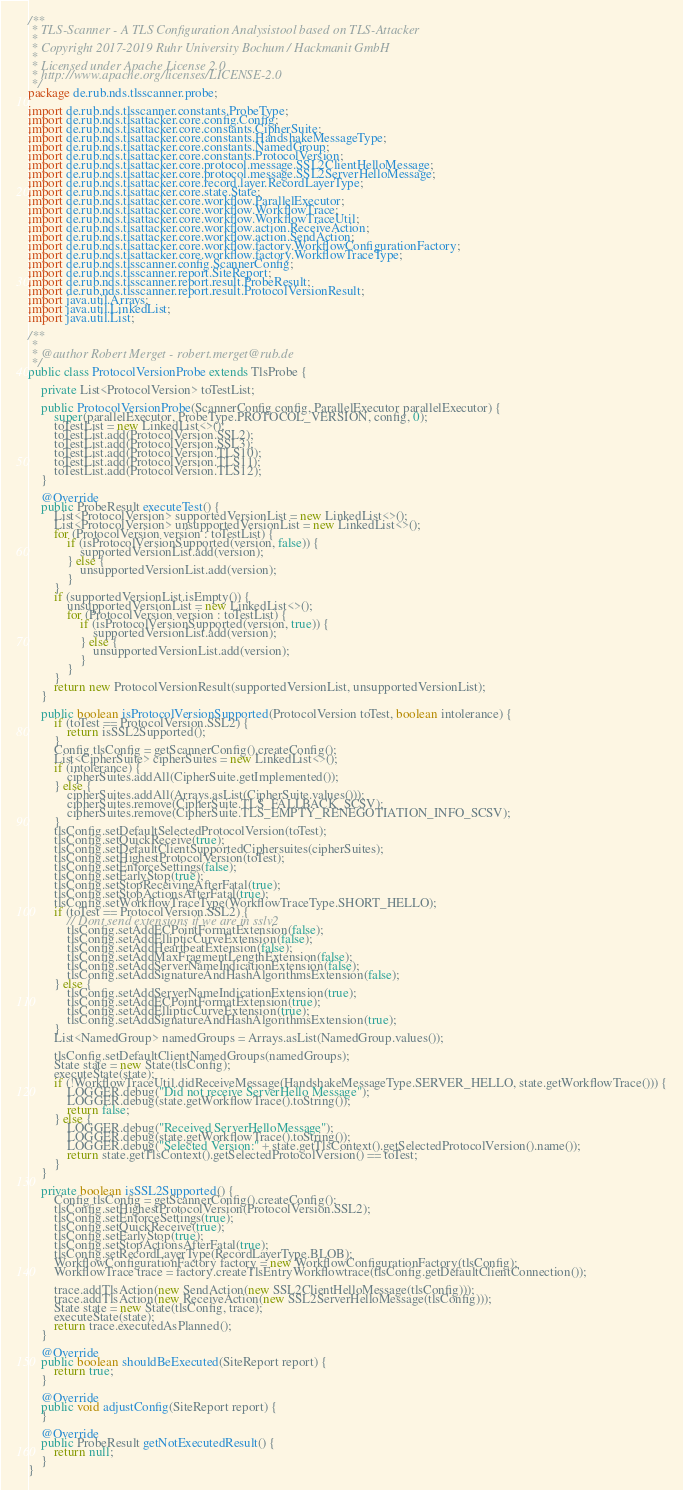Convert code to text. <code><loc_0><loc_0><loc_500><loc_500><_Java_>/**
 * TLS-Scanner - A TLS Configuration Analysistool based on TLS-Attacker
 *
 * Copyright 2017-2019 Ruhr University Bochum / Hackmanit GmbH
 *
 * Licensed under Apache License 2.0
 * http://www.apache.org/licenses/LICENSE-2.0
 */
package de.rub.nds.tlsscanner.probe;

import de.rub.nds.tlsscanner.constants.ProbeType;
import de.rub.nds.tlsattacker.core.config.Config;
import de.rub.nds.tlsattacker.core.constants.CipherSuite;
import de.rub.nds.tlsattacker.core.constants.HandshakeMessageType;
import de.rub.nds.tlsattacker.core.constants.NamedGroup;
import de.rub.nds.tlsattacker.core.constants.ProtocolVersion;
import de.rub.nds.tlsattacker.core.protocol.message.SSL2ClientHelloMessage;
import de.rub.nds.tlsattacker.core.protocol.message.SSL2ServerHelloMessage;
import de.rub.nds.tlsattacker.core.record.layer.RecordLayerType;
import de.rub.nds.tlsattacker.core.state.State;
import de.rub.nds.tlsattacker.core.workflow.ParallelExecutor;
import de.rub.nds.tlsattacker.core.workflow.WorkflowTrace;
import de.rub.nds.tlsattacker.core.workflow.WorkflowTraceUtil;
import de.rub.nds.tlsattacker.core.workflow.action.ReceiveAction;
import de.rub.nds.tlsattacker.core.workflow.action.SendAction;
import de.rub.nds.tlsattacker.core.workflow.factory.WorkflowConfigurationFactory;
import de.rub.nds.tlsattacker.core.workflow.factory.WorkflowTraceType;
import de.rub.nds.tlsscanner.config.ScannerConfig;
import de.rub.nds.tlsscanner.report.SiteReport;
import de.rub.nds.tlsscanner.report.result.ProbeResult;
import de.rub.nds.tlsscanner.report.result.ProtocolVersionResult;
import java.util.Arrays;
import java.util.LinkedList;
import java.util.List;

/**
 *
 * @author Robert Merget - robert.merget@rub.de
 */
public class ProtocolVersionProbe extends TlsProbe {

    private List<ProtocolVersion> toTestList;

    public ProtocolVersionProbe(ScannerConfig config, ParallelExecutor parallelExecutor) {
        super(parallelExecutor, ProbeType.PROTOCOL_VERSION, config, 0);
        toTestList = new LinkedList<>();
        toTestList.add(ProtocolVersion.SSL2);
        toTestList.add(ProtocolVersion.SSL3);
        toTestList.add(ProtocolVersion.TLS10);
        toTestList.add(ProtocolVersion.TLS11);
        toTestList.add(ProtocolVersion.TLS12);
    }

    @Override
    public ProbeResult executeTest() {
        List<ProtocolVersion> supportedVersionList = new LinkedList<>();
        List<ProtocolVersion> unsupportedVersionList = new LinkedList<>();
        for (ProtocolVersion version : toTestList) {
            if (isProtocolVersionSupported(version, false)) {
                supportedVersionList.add(version);
            } else {
                unsupportedVersionList.add(version);
            }
        }
        if (supportedVersionList.isEmpty()) {
            unsupportedVersionList = new LinkedList<>();
            for (ProtocolVersion version : toTestList) {
                if (isProtocolVersionSupported(version, true)) {
                    supportedVersionList.add(version);
                } else {
                    unsupportedVersionList.add(version);
                }
            }
        }
        return new ProtocolVersionResult(supportedVersionList, unsupportedVersionList);
    }

    public boolean isProtocolVersionSupported(ProtocolVersion toTest, boolean intolerance) {
        if (toTest == ProtocolVersion.SSL2) {
            return isSSL2Supported();
        }
        Config tlsConfig = getScannerConfig().createConfig();
        List<CipherSuite> cipherSuites = new LinkedList<>();
        if (intolerance) {
            cipherSuites.addAll(CipherSuite.getImplemented());
        } else {
            cipherSuites.addAll(Arrays.asList(CipherSuite.values()));
            cipherSuites.remove(CipherSuite.TLS_FALLBACK_SCSV);
            cipherSuites.remove(CipherSuite.TLS_EMPTY_RENEGOTIATION_INFO_SCSV);
        }
        tlsConfig.setDefaultSelectedProtocolVersion(toTest);
        tlsConfig.setQuickReceive(true);
        tlsConfig.setDefaultClientSupportedCiphersuites(cipherSuites);
        tlsConfig.setHighestProtocolVersion(toTest);
        tlsConfig.setEnforceSettings(false);
        tlsConfig.setEarlyStop(true);
        tlsConfig.setStopReceivingAfterFatal(true);
        tlsConfig.setStopActionsAfterFatal(true);
        tlsConfig.setWorkflowTraceType(WorkflowTraceType.SHORT_HELLO);
        if (toTest == ProtocolVersion.SSL2) {
            // Dont send extensions if we are in sslv2
            tlsConfig.setAddECPointFormatExtension(false);
            tlsConfig.setAddEllipticCurveExtension(false);
            tlsConfig.setAddHeartbeatExtension(false);
            tlsConfig.setAddMaxFragmentLengthExtension(false);
            tlsConfig.setAddServerNameIndicationExtension(false);
            tlsConfig.setAddSignatureAndHashAlgorithmsExtension(false);
        } else {
            tlsConfig.setAddServerNameIndicationExtension(true);
            tlsConfig.setAddECPointFormatExtension(true);
            tlsConfig.setAddEllipticCurveExtension(true);
            tlsConfig.setAddSignatureAndHashAlgorithmsExtension(true);
        }
        List<NamedGroup> namedGroups = Arrays.asList(NamedGroup.values());

        tlsConfig.setDefaultClientNamedGroups(namedGroups);
        State state = new State(tlsConfig);
        executeState(state);
        if (!WorkflowTraceUtil.didReceiveMessage(HandshakeMessageType.SERVER_HELLO, state.getWorkflowTrace())) {
            LOGGER.debug("Did not receive ServerHello Message");
            LOGGER.debug(state.getWorkflowTrace().toString());
            return false;
        } else {
            LOGGER.debug("Received ServerHelloMessage");
            LOGGER.debug(state.getWorkflowTrace().toString());
            LOGGER.debug("Selected Version:" + state.getTlsContext().getSelectedProtocolVersion().name());
            return state.getTlsContext().getSelectedProtocolVersion() == toTest;
        }
    }

    private boolean isSSL2Supported() {
        Config tlsConfig = getScannerConfig().createConfig();
        tlsConfig.setHighestProtocolVersion(ProtocolVersion.SSL2);
        tlsConfig.setEnforceSettings(true);
        tlsConfig.setQuickReceive(true);
        tlsConfig.setEarlyStop(true);
        tlsConfig.setStopActionsAfterFatal(true);
        tlsConfig.setRecordLayerType(RecordLayerType.BLOB);
        WorkflowConfigurationFactory factory = new WorkflowConfigurationFactory(tlsConfig);
        WorkflowTrace trace = factory.createTlsEntryWorkflowtrace(tlsConfig.getDefaultClientConnection());

        trace.addTlsAction(new SendAction(new SSL2ClientHelloMessage(tlsConfig)));
        trace.addTlsAction(new ReceiveAction(new SSL2ServerHelloMessage(tlsConfig)));
        State state = new State(tlsConfig, trace);
        executeState(state);
        return trace.executedAsPlanned();
    }

    @Override
    public boolean shouldBeExecuted(SiteReport report) {
        return true;
    }

    @Override
    public void adjustConfig(SiteReport report) {
    }

    @Override
    public ProbeResult getNotExecutedResult() {
        return null;
    }
}
</code> 